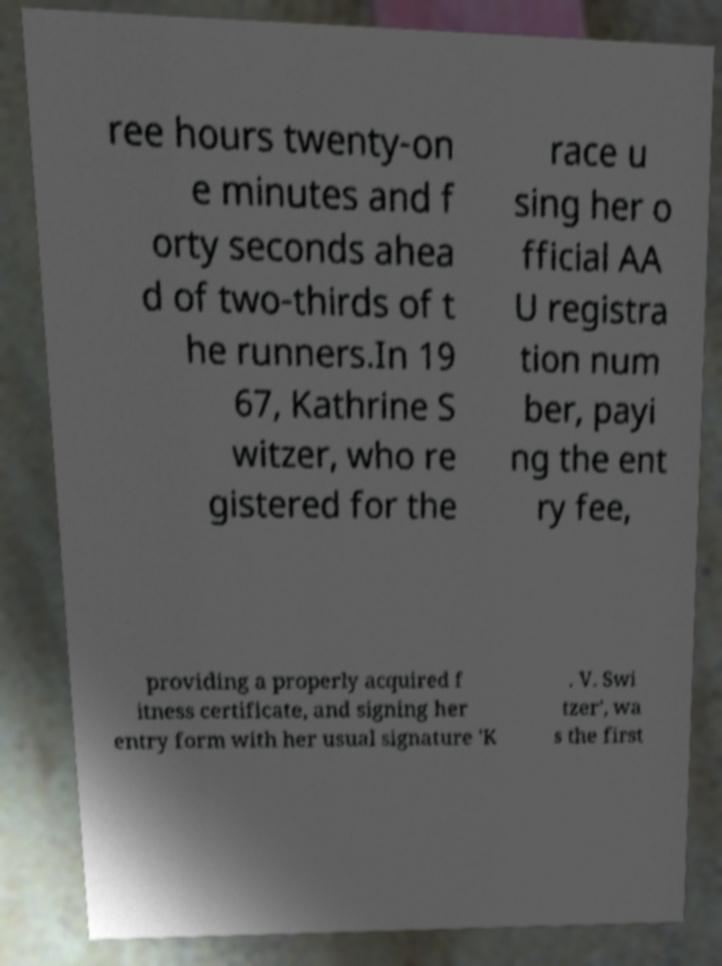Can you accurately transcribe the text from the provided image for me? ree hours twenty-on e minutes and f orty seconds ahea d of two-thirds of t he runners.In 19 67, Kathrine S witzer, who re gistered for the race u sing her o fficial AA U registra tion num ber, payi ng the ent ry fee, providing a properly acquired f itness certificate, and signing her entry form with her usual signature 'K . V. Swi tzer', wa s the first 